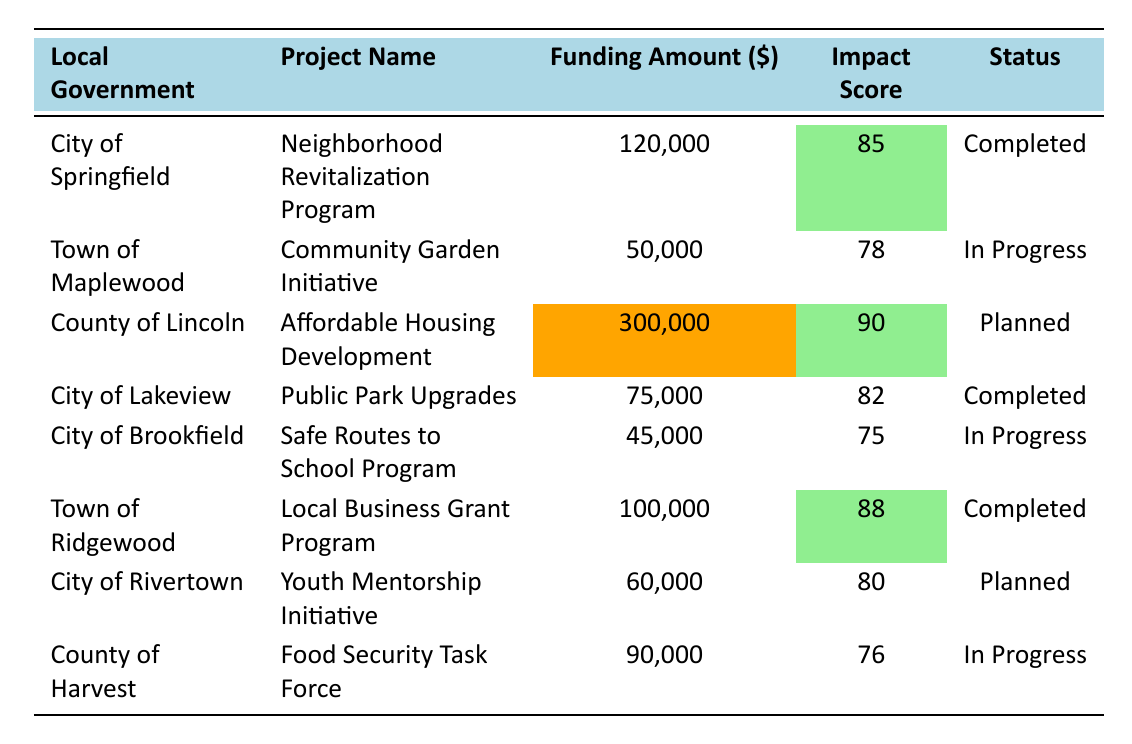What is the funding amount for the Affordable Housing Development project? The funding amount for the Affordable Housing Development project located in the County of Lincoln is explicitly stated in the table as 300,000.
Answer: 300,000 How many projects have a community impact score of 85 or above? To find the number of projects with a community impact score of 85 or above, we check the scores listed in the table: 85 (2), 90 (1), and 88 (1). This totals to 4 projects.
Answer: 4 Which city received the highest funding allocation? Looking at the funding amounts, the County of Lincoln received the highest allocation of 300,000, which can be identified directly from the funding amount column.
Answer: 300,000 Is the Local Business Grant Program completed? The status of the Local Business Grant Program is verified in the table, where it is listed as "Completed."
Answer: Yes What is the total funding amount allocated to projects that are currently in progress? The funding amounts for projects marked as "In Progress" are 50,000 (Community Garden Initiative), 45,000 (Safe Routes to School Program), and 90,000 (Food Security Task Force). The total is calculated by adding these amounts: 50,000 + 45,000 + 90,000 = 185,000.
Answer: 185,000 Which project has the highest community impact score, and what is that score? By reviewing the community impact scores, the project with the highest score is the Affordable Housing Development with a score of 90. This can be confirmed by scanning the impact score column.
Answer: Affordable Housing Development, 90 Are there any projects in Springfield that are still in progress? Checking the status for Springfield, the Neighborhood Revitalization Program is marked as "Completed," indicating there are no ongoing projects in Springfield.
Answer: No What is the average community impact score of all completed projects? The completed projects are Neighborhood Revitalization Program (85), Public Park Upgrades (82), and Local Business Grant Program (88). To find the average, we sum the scores: 85 + 82 + 88 = 255, and then divide by the number of projects (3): 255 / 3 = 85.
Answer: 85 How many projects are planned, and what is their total funding amount? The planned projects listed in the table are the Affordable Housing Development and the Youth Mentorship Initiative. The total amount for both is 300,000 + 60,000 = 360,000.
Answer: 2, 360,000 Is the funding amount of the Community Garden Initiative higher than that of the Safe Routes to School Program? By comparing the funding amounts, the Community Garden Initiative received 50,000, while the Safe Routes to School Program received 45,000. Since 50,000 is greater than 45,000, the statement is true.
Answer: Yes 